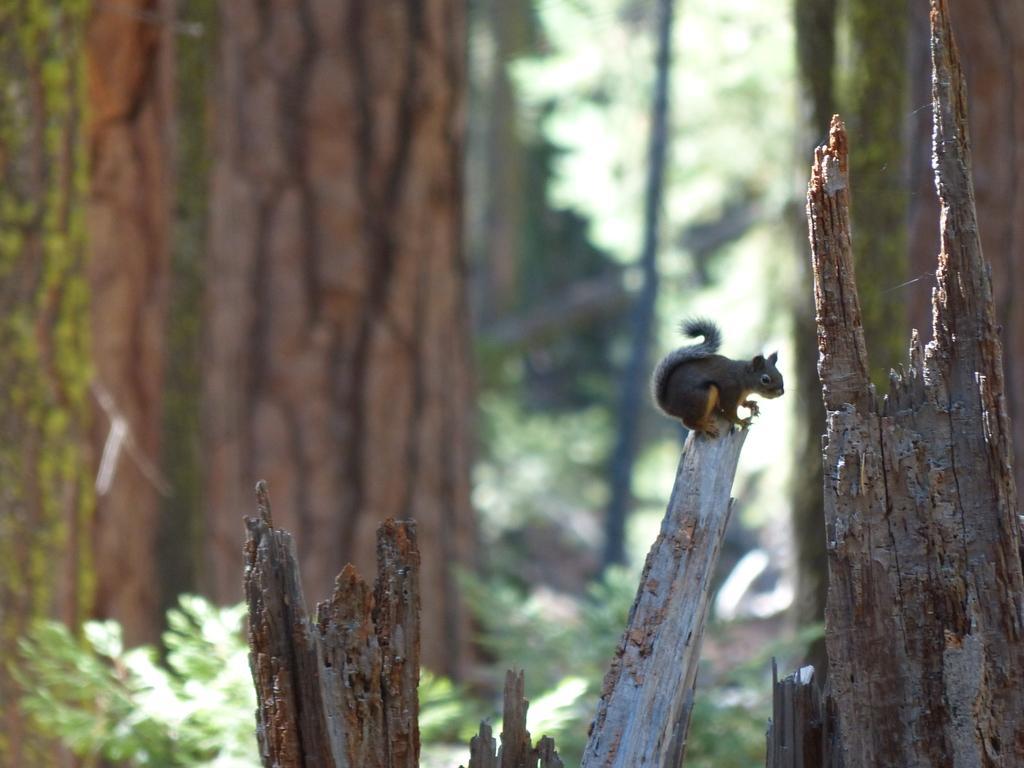Please provide a concise description of this image. There are wooden pieces. On the piece there is a squirrel. In the background it is blurred and there are plants. 